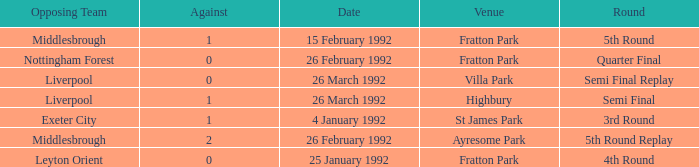What was the round for Villa Park? Semi Final Replay. Could you parse the entire table as a dict? {'header': ['Opposing Team', 'Against', 'Date', 'Venue', 'Round'], 'rows': [['Middlesbrough', '1', '15 February 1992', 'Fratton Park', '5th Round'], ['Nottingham Forest', '0', '26 February 1992', 'Fratton Park', 'Quarter Final'], ['Liverpool', '0', '26 March 1992', 'Villa Park', 'Semi Final Replay'], ['Liverpool', '1', '26 March 1992', 'Highbury', 'Semi Final'], ['Exeter City', '1', '4 January 1992', 'St James Park', '3rd Round'], ['Middlesbrough', '2', '26 February 1992', 'Ayresome Park', '5th Round Replay'], ['Leyton Orient', '0', '25 January 1992', 'Fratton Park', '4th Round']]} 